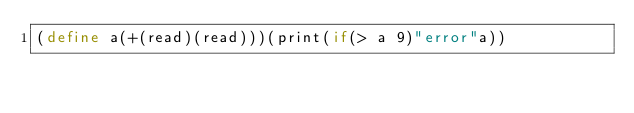<code> <loc_0><loc_0><loc_500><loc_500><_Scheme_>(define a(+(read)(read)))(print(if(> a 9)"error"a))</code> 